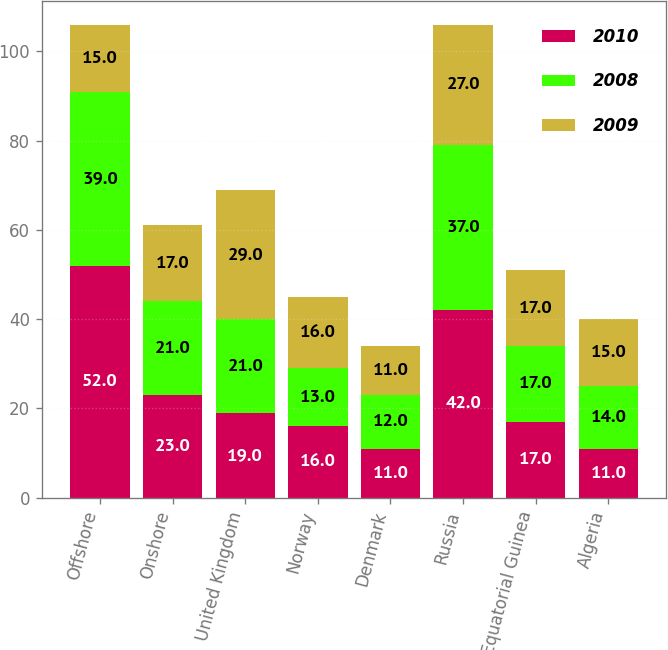<chart> <loc_0><loc_0><loc_500><loc_500><stacked_bar_chart><ecel><fcel>Offshore<fcel>Onshore<fcel>United Kingdom<fcel>Norway<fcel>Denmark<fcel>Russia<fcel>Equatorial Guinea<fcel>Algeria<nl><fcel>2010<fcel>52<fcel>23<fcel>19<fcel>16<fcel>11<fcel>42<fcel>17<fcel>11<nl><fcel>2008<fcel>39<fcel>21<fcel>21<fcel>13<fcel>12<fcel>37<fcel>17<fcel>14<nl><fcel>2009<fcel>15<fcel>17<fcel>29<fcel>16<fcel>11<fcel>27<fcel>17<fcel>15<nl></chart> 